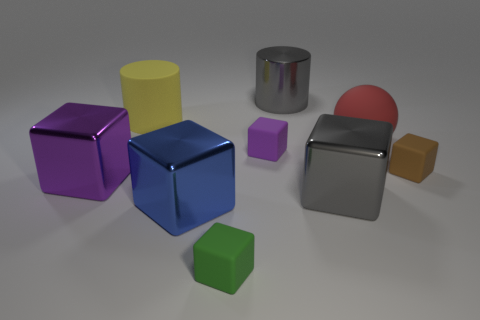There is a sphere; is its color the same as the block that is to the left of the blue cube?
Your answer should be very brief. No. Are there fewer red objects than big blue matte blocks?
Offer a very short reply. No. Is the number of large matte objects to the right of the matte sphere greater than the number of large gray metallic cubes that are on the left side of the blue metal block?
Your response must be concise. No. Is the material of the red sphere the same as the blue block?
Ensure brevity in your answer.  No. What number of large gray objects are in front of the gray thing behind the large purple metallic cube?
Give a very brief answer. 1. Is the color of the small rubber block in front of the purple metal object the same as the large ball?
Ensure brevity in your answer.  No. How many objects are either large blue objects or cubes that are behind the blue thing?
Keep it short and to the point. 5. Does the purple thing that is to the right of the large blue cube have the same shape as the matte object in front of the large blue shiny thing?
Your response must be concise. Yes. Is there any other thing that has the same color as the rubber cylinder?
Offer a very short reply. No. There is a large red object that is the same material as the green block; what is its shape?
Offer a very short reply. Sphere. 